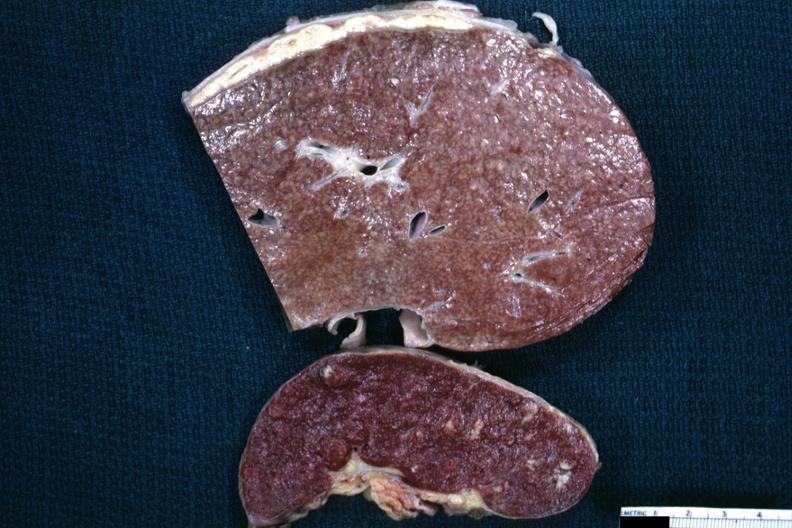where is this area in the body?
Answer the question using a single word or phrase. Abdomen 